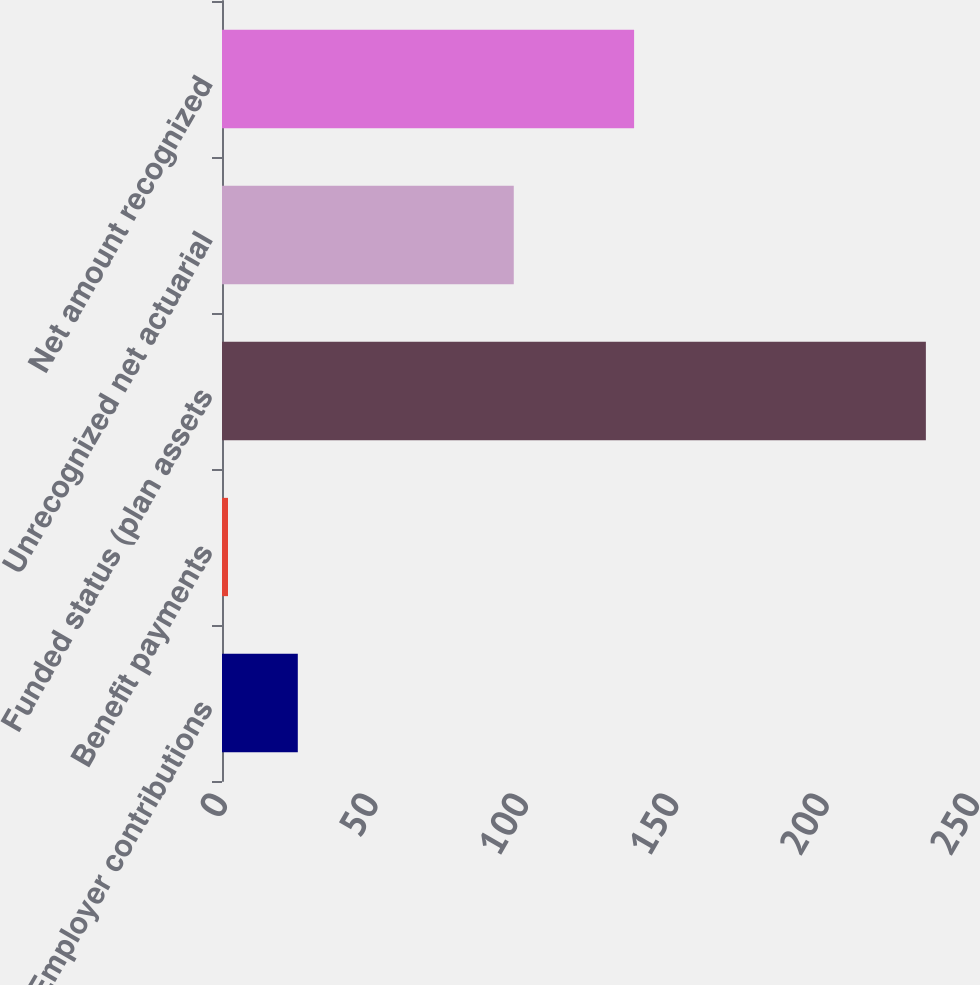<chart> <loc_0><loc_0><loc_500><loc_500><bar_chart><fcel>Employer contributions<fcel>Benefit payments<fcel>Funded status (plan assets<fcel>Unrecognized net actuarial<fcel>Net amount recognized<nl><fcel>25.2<fcel>2<fcel>234<fcel>97<fcel>137<nl></chart> 